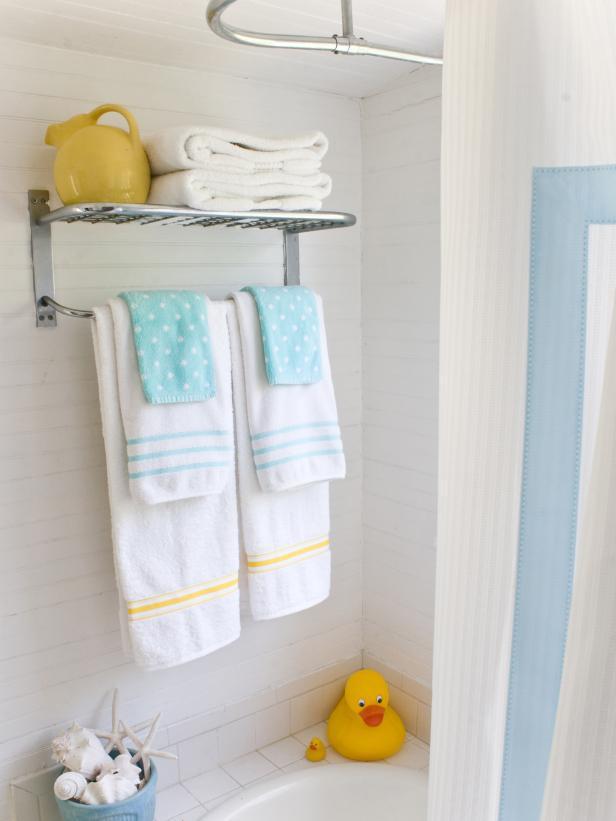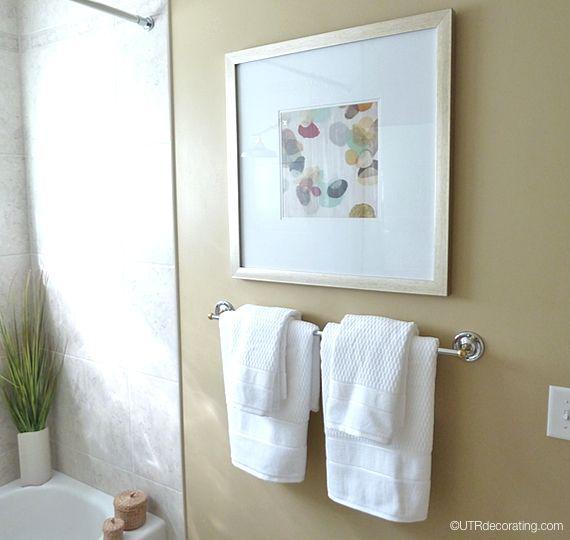The first image is the image on the left, the second image is the image on the right. Considering the images on both sides, is "In at  least one image there are two sets of hand towels next to a striped shower curtain." valid? Answer yes or no. Yes. The first image is the image on the left, the second image is the image on the right. Examine the images to the left and right. Is the description "One image features side-by-side white towels with smaller towels draped over them on a bar to the right of a shower." accurate? Answer yes or no. Yes. 